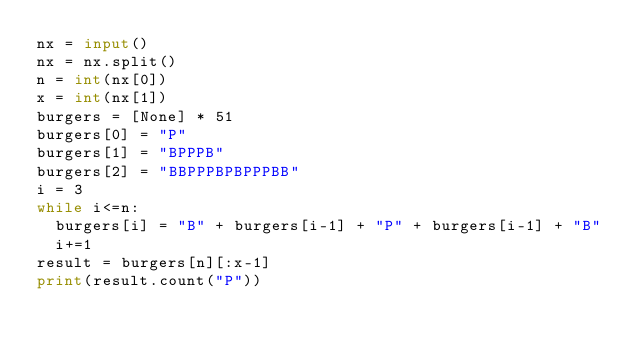<code> <loc_0><loc_0><loc_500><loc_500><_Python_>nx = input()
nx = nx.split()
n = int(nx[0])
x = int(nx[1])
burgers = [None] * 51
burgers[0] = "P"
burgers[1] = "BPPPB"
burgers[2] = "BBPPPBPBPPPBB"
i = 3
while i<=n:
  burgers[i] = "B" + burgers[i-1] + "P" + burgers[i-1] + "B"
  i+=1
result = burgers[n][:x-1]
print(result.count("P"))</code> 